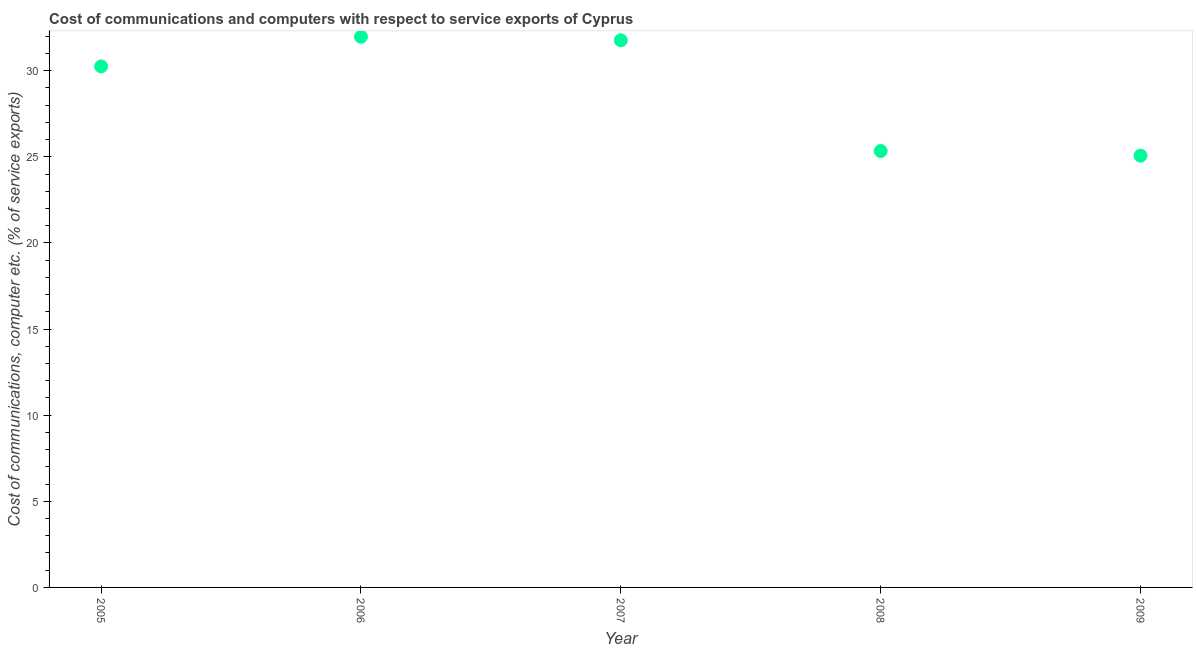What is the cost of communications and computer in 2007?
Provide a short and direct response. 31.77. Across all years, what is the maximum cost of communications and computer?
Make the answer very short. 31.97. Across all years, what is the minimum cost of communications and computer?
Offer a terse response. 25.07. In which year was the cost of communications and computer maximum?
Keep it short and to the point. 2006. What is the sum of the cost of communications and computer?
Make the answer very short. 144.39. What is the difference between the cost of communications and computer in 2005 and 2006?
Your response must be concise. -1.72. What is the average cost of communications and computer per year?
Ensure brevity in your answer.  28.88. What is the median cost of communications and computer?
Provide a short and direct response. 30.25. In how many years, is the cost of communications and computer greater than 1 %?
Keep it short and to the point. 5. What is the ratio of the cost of communications and computer in 2006 to that in 2007?
Your answer should be very brief. 1.01. What is the difference between the highest and the second highest cost of communications and computer?
Provide a succinct answer. 0.21. Is the sum of the cost of communications and computer in 2006 and 2009 greater than the maximum cost of communications and computer across all years?
Your answer should be very brief. Yes. What is the difference between the highest and the lowest cost of communications and computer?
Provide a short and direct response. 6.9. How many years are there in the graph?
Provide a short and direct response. 5. Does the graph contain grids?
Offer a very short reply. No. What is the title of the graph?
Offer a terse response. Cost of communications and computers with respect to service exports of Cyprus. What is the label or title of the Y-axis?
Provide a short and direct response. Cost of communications, computer etc. (% of service exports). What is the Cost of communications, computer etc. (% of service exports) in 2005?
Offer a very short reply. 30.25. What is the Cost of communications, computer etc. (% of service exports) in 2006?
Your response must be concise. 31.97. What is the Cost of communications, computer etc. (% of service exports) in 2007?
Your answer should be compact. 31.77. What is the Cost of communications, computer etc. (% of service exports) in 2008?
Provide a short and direct response. 25.34. What is the Cost of communications, computer etc. (% of service exports) in 2009?
Give a very brief answer. 25.07. What is the difference between the Cost of communications, computer etc. (% of service exports) in 2005 and 2006?
Offer a very short reply. -1.72. What is the difference between the Cost of communications, computer etc. (% of service exports) in 2005 and 2007?
Give a very brief answer. -1.52. What is the difference between the Cost of communications, computer etc. (% of service exports) in 2005 and 2008?
Offer a terse response. 4.91. What is the difference between the Cost of communications, computer etc. (% of service exports) in 2005 and 2009?
Provide a succinct answer. 5.18. What is the difference between the Cost of communications, computer etc. (% of service exports) in 2006 and 2007?
Provide a short and direct response. 0.21. What is the difference between the Cost of communications, computer etc. (% of service exports) in 2006 and 2008?
Offer a terse response. 6.63. What is the difference between the Cost of communications, computer etc. (% of service exports) in 2006 and 2009?
Your answer should be very brief. 6.9. What is the difference between the Cost of communications, computer etc. (% of service exports) in 2007 and 2008?
Make the answer very short. 6.43. What is the difference between the Cost of communications, computer etc. (% of service exports) in 2007 and 2009?
Your answer should be compact. 6.7. What is the difference between the Cost of communications, computer etc. (% of service exports) in 2008 and 2009?
Your response must be concise. 0.27. What is the ratio of the Cost of communications, computer etc. (% of service exports) in 2005 to that in 2006?
Your answer should be compact. 0.95. What is the ratio of the Cost of communications, computer etc. (% of service exports) in 2005 to that in 2008?
Provide a short and direct response. 1.19. What is the ratio of the Cost of communications, computer etc. (% of service exports) in 2005 to that in 2009?
Your answer should be very brief. 1.21. What is the ratio of the Cost of communications, computer etc. (% of service exports) in 2006 to that in 2008?
Your answer should be compact. 1.26. What is the ratio of the Cost of communications, computer etc. (% of service exports) in 2006 to that in 2009?
Ensure brevity in your answer.  1.27. What is the ratio of the Cost of communications, computer etc. (% of service exports) in 2007 to that in 2008?
Ensure brevity in your answer.  1.25. What is the ratio of the Cost of communications, computer etc. (% of service exports) in 2007 to that in 2009?
Make the answer very short. 1.27. What is the ratio of the Cost of communications, computer etc. (% of service exports) in 2008 to that in 2009?
Your answer should be compact. 1.01. 